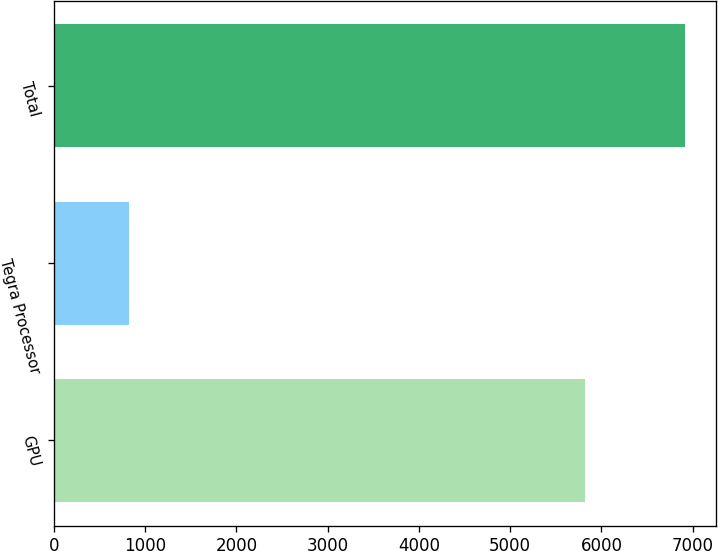<chart> <loc_0><loc_0><loc_500><loc_500><bar_chart><fcel>GPU<fcel>Tegra Processor<fcel>Total<nl><fcel>5822<fcel>824<fcel>6910<nl></chart> 